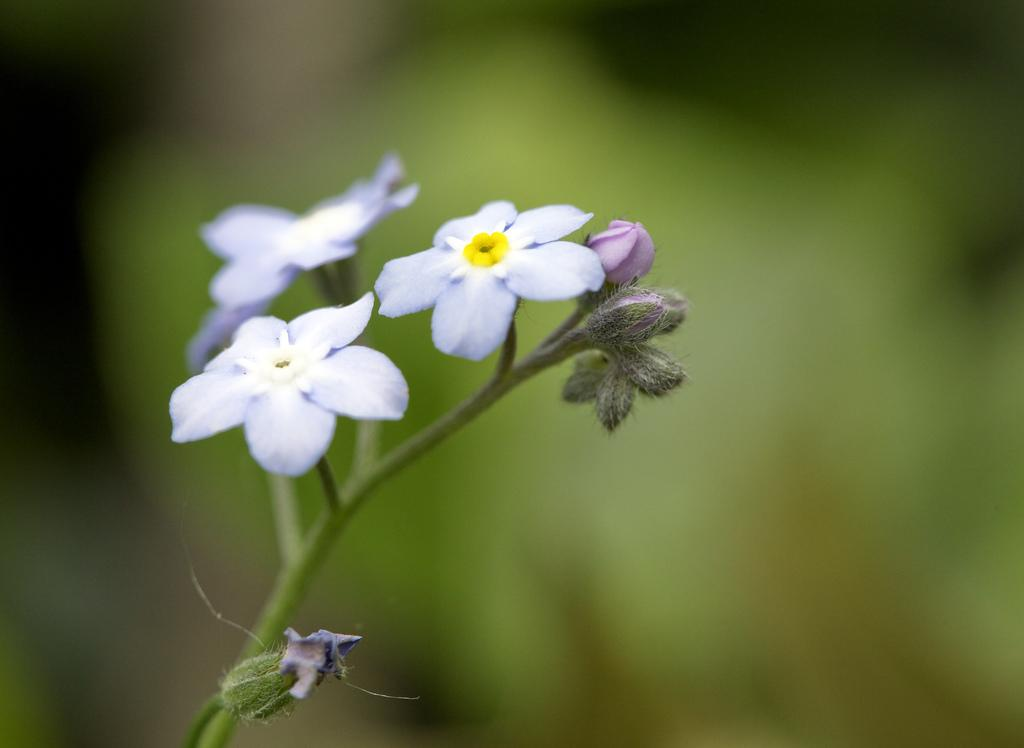What type of plant life is present in the image? There are flowers in the image. How are the flowers connected to the plant? The flowers are attached to the stem of a plant. What can be observed about the background of the image? The backdrop of the image is blurred. How many cattle can be seen grazing in the image? There are no cattle present in the image; it features flowers and a blurred backdrop. 